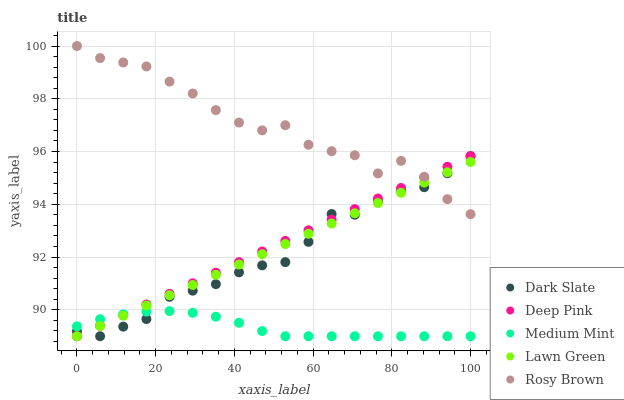Does Medium Mint have the minimum area under the curve?
Answer yes or no. Yes. Does Rosy Brown have the maximum area under the curve?
Answer yes or no. Yes. Does Dark Slate have the minimum area under the curve?
Answer yes or no. No. Does Dark Slate have the maximum area under the curve?
Answer yes or no. No. Is Deep Pink the smoothest?
Answer yes or no. Yes. Is Rosy Brown the roughest?
Answer yes or no. Yes. Is Dark Slate the smoothest?
Answer yes or no. No. Is Dark Slate the roughest?
Answer yes or no. No. Does Medium Mint have the lowest value?
Answer yes or no. Yes. Does Rosy Brown have the lowest value?
Answer yes or no. No. Does Rosy Brown have the highest value?
Answer yes or no. Yes. Does Dark Slate have the highest value?
Answer yes or no. No. Is Medium Mint less than Rosy Brown?
Answer yes or no. Yes. Is Rosy Brown greater than Medium Mint?
Answer yes or no. Yes. Does Lawn Green intersect Dark Slate?
Answer yes or no. Yes. Is Lawn Green less than Dark Slate?
Answer yes or no. No. Is Lawn Green greater than Dark Slate?
Answer yes or no. No. Does Medium Mint intersect Rosy Brown?
Answer yes or no. No. 